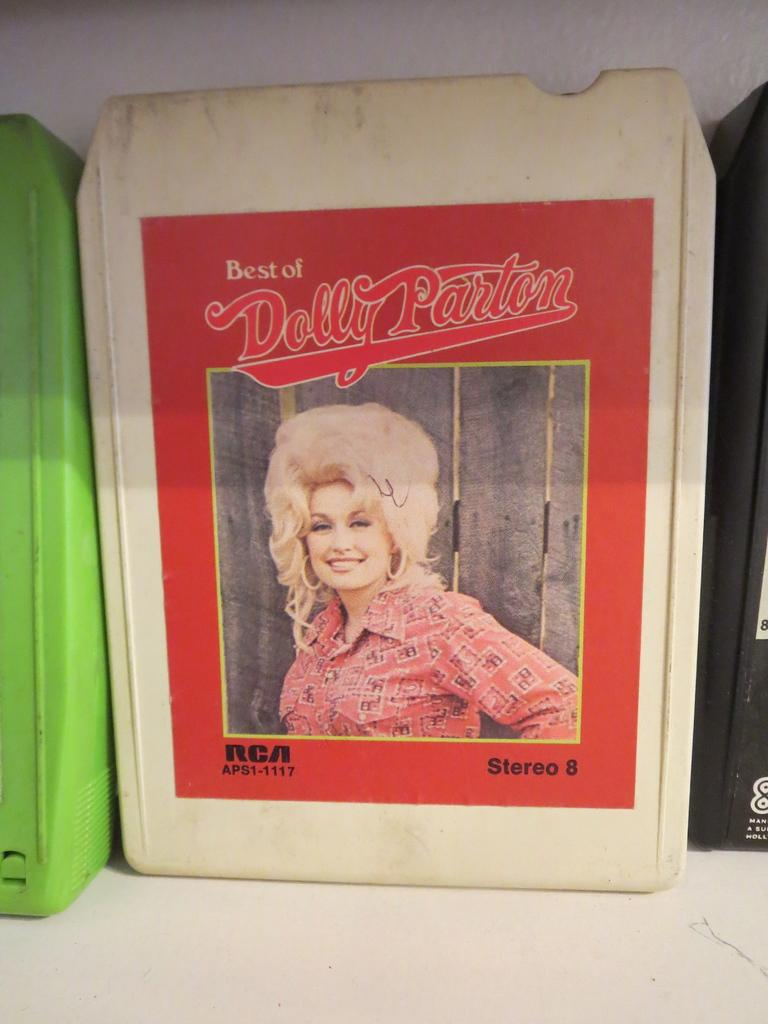What is the main subject in the image? There is an object in the image. What can be seen on the object? The object has a poster of a woman. What is written on the poster? There is text written on the poster. How many bones can be seen in the image? There are no bones visible in the image. What type of trail is depicted in the image? There is no trail present in the image. 